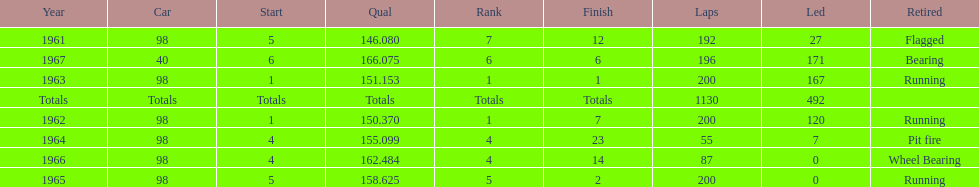What is the difference between the qualfying time in 1967 and 1965? 7.45. Would you be able to parse every entry in this table? {'header': ['Year', 'Car', 'Start', 'Qual', 'Rank', 'Finish', 'Laps', 'Led', 'Retired'], 'rows': [['1961', '98', '5', '146.080', '7', '12', '192', '27', 'Flagged'], ['1967', '40', '6', '166.075', '6', '6', '196', '171', 'Bearing'], ['1963', '98', '1', '151.153', '1', '1', '200', '167', 'Running'], ['Totals', 'Totals', 'Totals', 'Totals', 'Totals', 'Totals', '1130', '492', ''], ['1962', '98', '1', '150.370', '1', '7', '200', '120', 'Running'], ['1964', '98', '4', '155.099', '4', '23', '55', '7', 'Pit fire'], ['1966', '98', '4', '162.484', '4', '14', '87', '0', 'Wheel Bearing'], ['1965', '98', '5', '158.625', '5', '2', '200', '0', 'Running']]} 